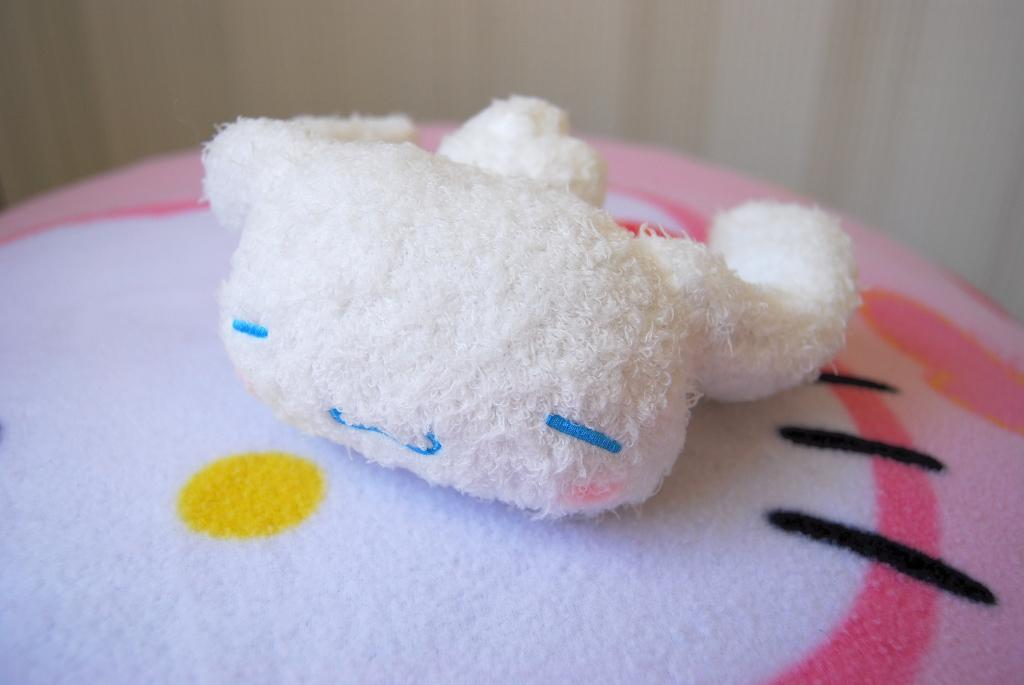What is the main subject in the center of the image? There is a toy in the center of the image. What can be seen in the background of the image? There is a wall in the background of the image. What is the value of the farm in the image? There is no farm present in the image, so it is not possible to determine its value. 